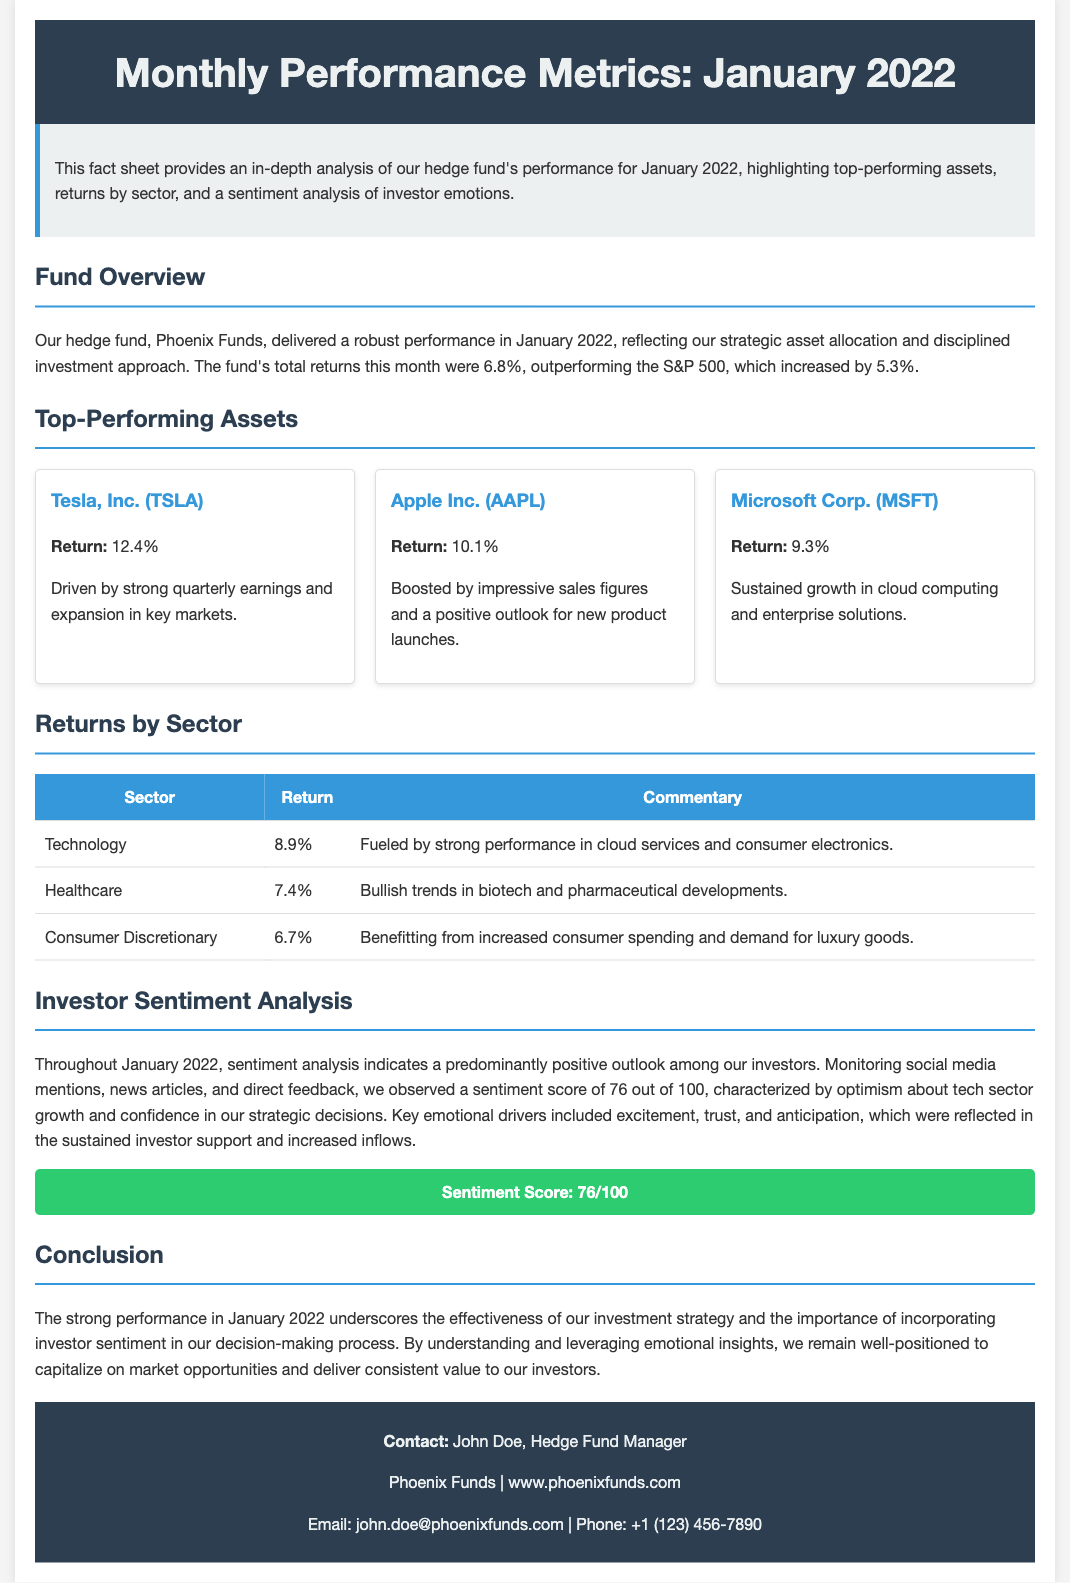What was the fund's total return in January 2022? The document states that the fund's total returns this month were 6.8%.
Answer: 6.8% Which asset had the highest return? The highest return among the listed top-performing assets was for Tesla, Inc.
Answer: Tesla, Inc. (TSLA) What was the sentiment score for January 2022? The sentiment score indicated in the document is 76 out of 100.
Answer: 76/100 What was the return for the Technology sector? The Technology sector return mentioned in the document is 8.9%.
Answer: 8.9% Which company is associated with a return of 10.1%? The company with a return of 10.1% is Apple Inc.
Answer: Apple Inc. (AAPL) What emotional drivers were highlighted in the sentiment analysis? The key emotional drivers noted are excitement, trust, and anticipation.
Answer: Excitement, trust, and anticipation Which sector had the lowest return reported? The sector with the lowest return reported is Consumer Discretionary with 6.7%.
Answer: Consumer Discretionary How many top-performing assets were listed in the document? The document lists three top-performing assets.
Answer: Three 